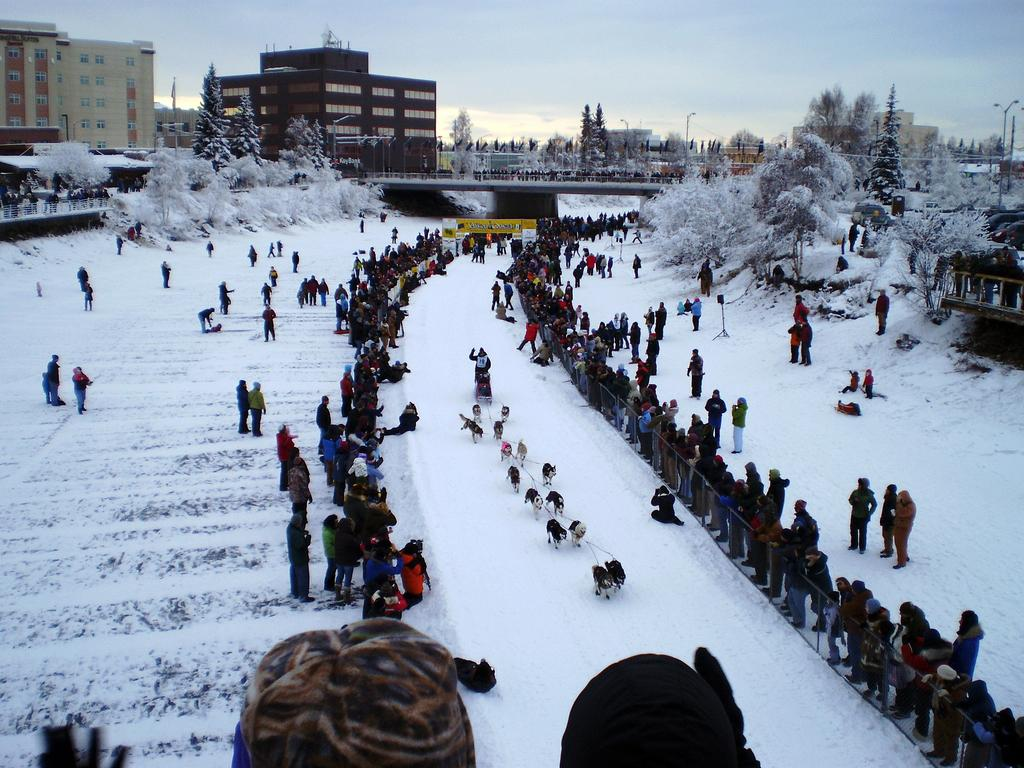What is the condition of the land in the image? The land is covered with snow. Can you describe the people in the image? There is a person and people standing in the image. What animals are present in the image? There are dogs in the image. What can be seen in the background of the image? There are trees, buildings, light poles, and a bridge in the background of the image. What is the weather like in the image? The sky is cloudy in the image. How many jellyfish can be seen swimming under the bridge in the image? There are no jellyfish present in the image, and therefore no such activity can be observed. What type of bell is hanging from the light pole in the image? There is no bell hanging from the light pole in the image. 